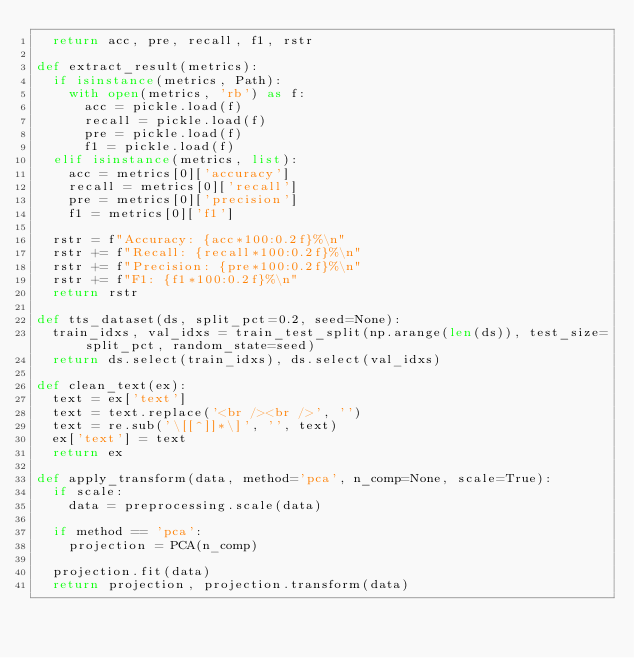<code> <loc_0><loc_0><loc_500><loc_500><_Python_>  return acc, pre, recall, f1, rstr

def extract_result(metrics):
  if isinstance(metrics, Path):
    with open(metrics, 'rb') as f:
      acc = pickle.load(f)
      recall = pickle.load(f)
      pre = pickle.load(f)    
      f1 = pickle.load(f)
  elif isinstance(metrics, list):
    acc = metrics[0]['accuracy']
    recall = metrics[0]['recall']
    pre = metrics[0]['precision']    
    f1 = metrics[0]['f1']

  rstr = f"Accuracy: {acc*100:0.2f}%\n"
  rstr += f"Recall: {recall*100:0.2f}%\n"
  rstr += f"Precision: {pre*100:0.2f}%\n"
  rstr += f"F1: {f1*100:0.2f}%\n"  
  return rstr

def tts_dataset(ds, split_pct=0.2, seed=None):
  train_idxs, val_idxs = train_test_split(np.arange(len(ds)), test_size=split_pct, random_state=seed)
  return ds.select(train_idxs), ds.select(val_idxs)

def clean_text(ex):
  text = ex['text']
  text = text.replace('<br /><br />', '')
  text = re.sub('\[[^]]*\]', '', text)
  ex['text'] = text
  return ex

def apply_transform(data, method='pca', n_comp=None, scale=True):
  if scale:
    data = preprocessing.scale(data)
    
  if method == 'pca':
    projection = PCA(n_comp)
    
  projection.fit(data)
  return projection, projection.transform(data)</code> 